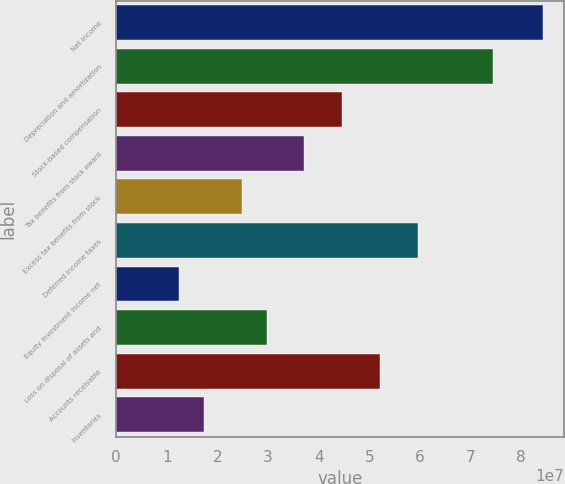Convert chart. <chart><loc_0><loc_0><loc_500><loc_500><bar_chart><fcel>Net income<fcel>Depreciation and amortization<fcel>Stock-based compensation<fcel>Tax benefits from stock award<fcel>Excess tax benefits from stock<fcel>Deferred income taxes<fcel>Equity investment income net<fcel>Loss on disposal of assets and<fcel>Accounts receivable<fcel>Inventories<nl><fcel>8.43506e+07<fcel>7.44271e+07<fcel>4.46564e+07<fcel>3.72137e+07<fcel>2.48093e+07<fcel>5.95417e+07<fcel>1.24048e+07<fcel>2.9771e+07<fcel>5.2099e+07<fcel>1.73666e+07<nl></chart> 